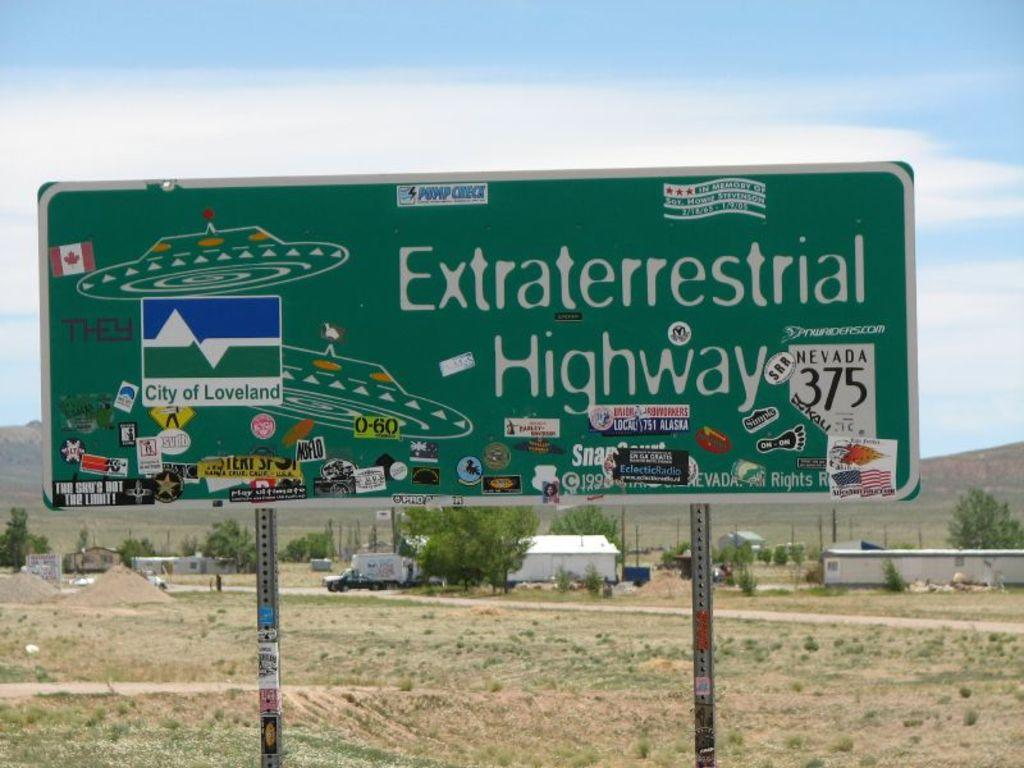<image>
Share a concise interpretation of the image provided. A sign for the Extraterrestrial Highway in Nevada. 